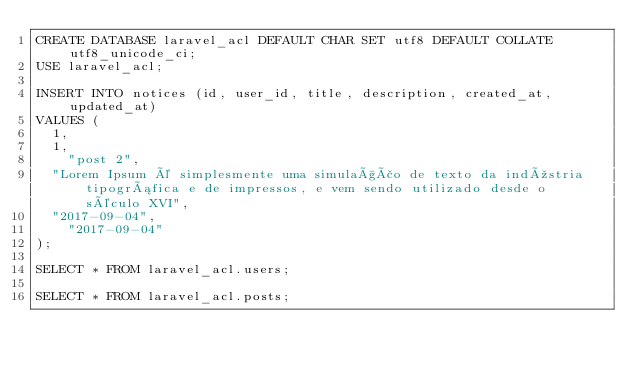<code> <loc_0><loc_0><loc_500><loc_500><_SQL_>CREATE DATABASE laravel_acl DEFAULT CHAR SET utf8 DEFAULT COLLATE utf8_unicode_ci;
USE laravel_acl;

INSERT INTO notices (id, user_id, title, description, created_at, updated_at) 
VALUES (
	1, 
	1, 
    "post 2", 
	"Lorem Ipsum é simplesmente uma simulação de texto da indústria tipográfica e de impressos, e vem sendo utilizado desde o século XVI",
	"2017-09-04",
    "2017-09-04"
);

SELECT * FROM laravel_acl.users;

SELECT * FROM laravel_acl.posts;</code> 